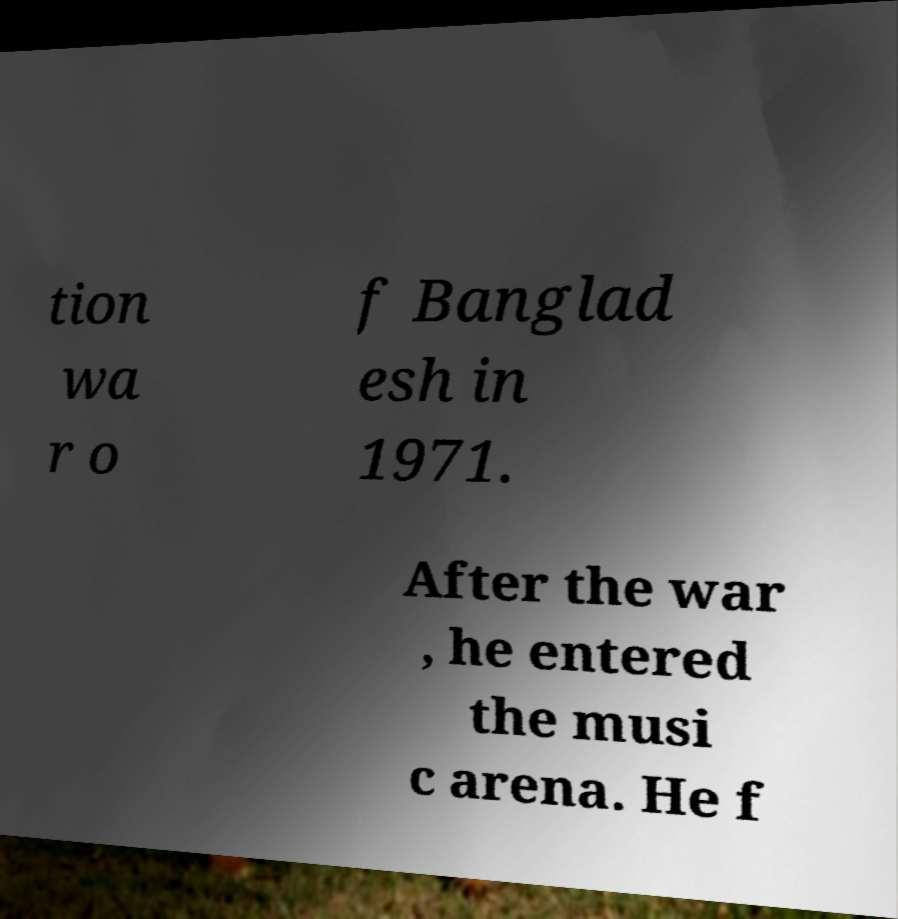Can you read and provide the text displayed in the image?This photo seems to have some interesting text. Can you extract and type it out for me? tion wa r o f Banglad esh in 1971. After the war , he entered the musi c arena. He f 